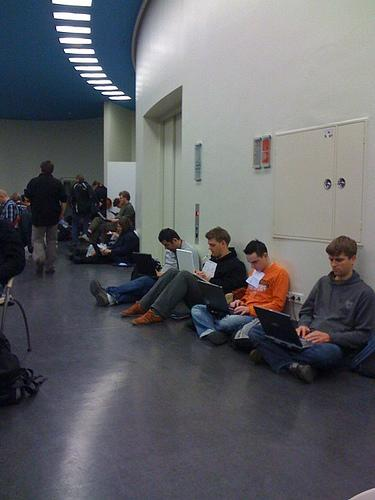Create a short haiku inspired by the image. Elevator waits. List three main colors visible in the picture. Gray, orange, and blue are prominent colors displayed by the clothing and laptops in the image. Write a sentence describing the background element in the image. There is an elevator with closed doors and buttons in the background, indicating an indoor setting. Write a concise sentence describing what the central person in the image is doing. A male in a gray hoodie is sitting on the floor, using a laptop on his lap while crossing his legs. What is the most prominent accessory present in the image? The most prominent accessory in the image is a variety of laptops being used by people sitting on the floor. Mention the types of computer devices visible in the image. There are multiple laptops, including gray and white ones, being used by people sitting on the floor. Describe the collective activity showcased in the image. The image shows a group of people sitting on the floor, engrossed in their laptops, possibly collaborating or working on individual tasks. Imagine a short story based on the scene, share the opening line. In a small and quiet corner of the bustling convention center, a group of coders gathered to share their skills and exchange ideas. Provide a brief description of the most prominent apparel worn by individuals in the image. People in the image are wearing various clothing, such as gray and black hoodies, an orange shirt, and blue jeans. Describe the atmosphere conveyed by the image. The image displays a casual gathering of people sitting on the floor, engaged in activities on their laptops. 